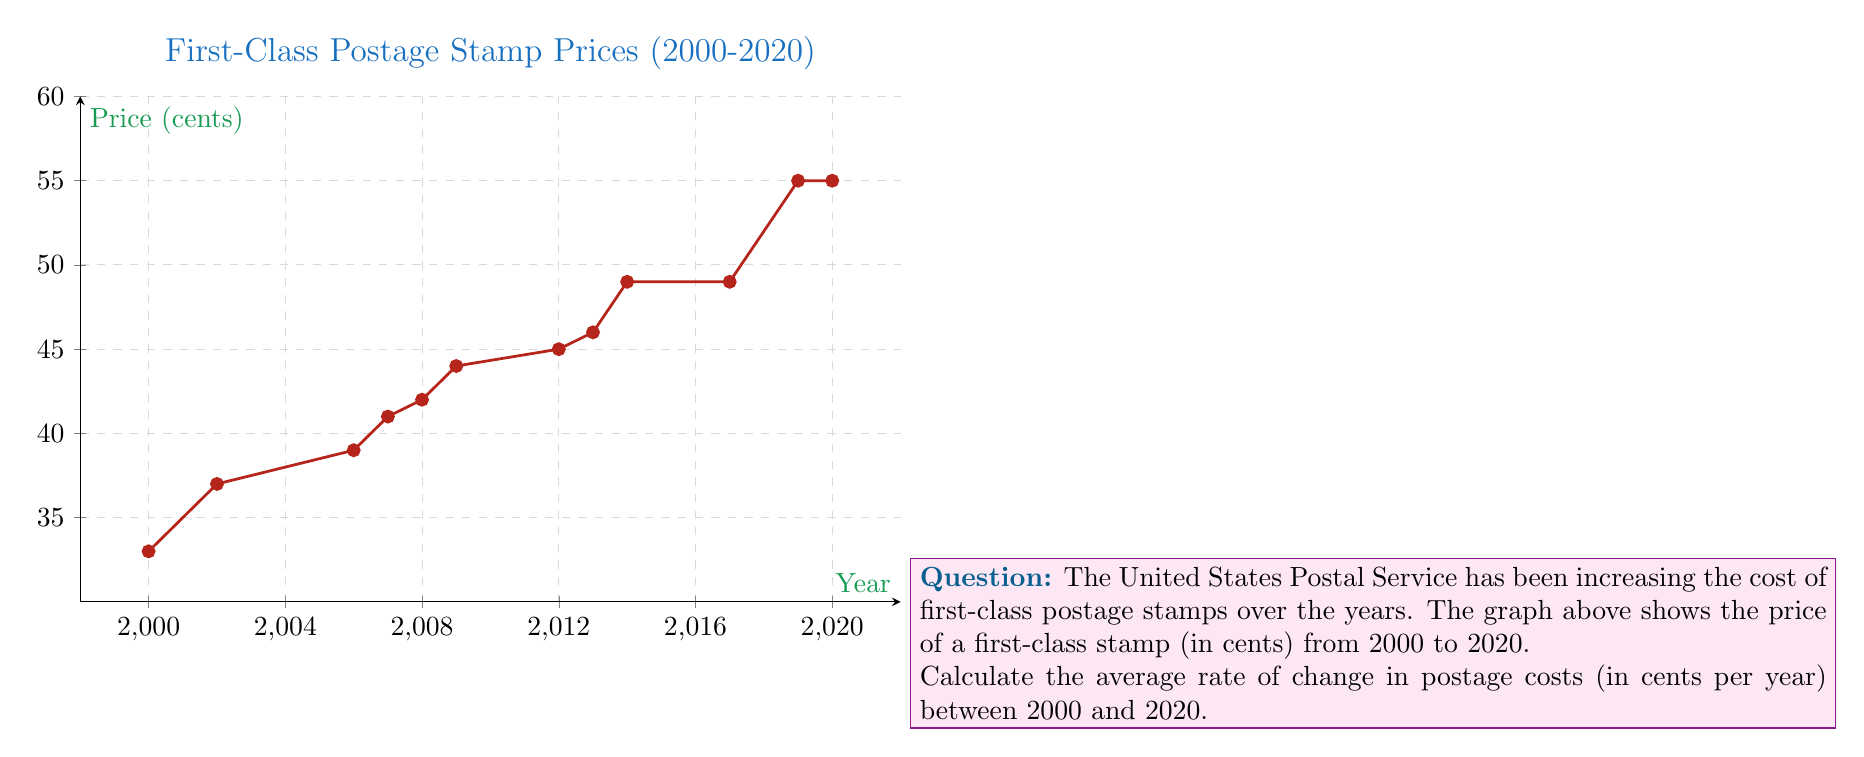Give your solution to this math problem. To calculate the average rate of change in postage costs between 2000 and 2020, we need to use the formula:

$$ \text{Average rate of change} = \frac{\text{Change in y}}{\text{Change in x}} = \frac{\Delta y}{\Delta x} $$

Where:
- $\Delta y$ is the change in postage cost
- $\Delta x$ is the change in time

Step 1: Identify the postage costs at the start and end points.
- In 2000: 33 cents
- In 2020: 55 cents

Step 2: Calculate $\Delta y$ (change in postage cost).
$\Delta y = 55 - 33 = 22$ cents

Step 3: Calculate $\Delta x$ (change in time).
$\Delta x = 2020 - 2000 = 20$ years

Step 4: Apply the formula for average rate of change.
$$ \text{Average rate of change} = \frac{\Delta y}{\Delta x} = \frac{22 \text{ cents}}{20 \text{ years}} = 1.1 \text{ cents per year} $$

Therefore, the average rate of change in postage costs between 2000 and 2020 is 1.1 cents per year.
Answer: 1.1 cents/year 